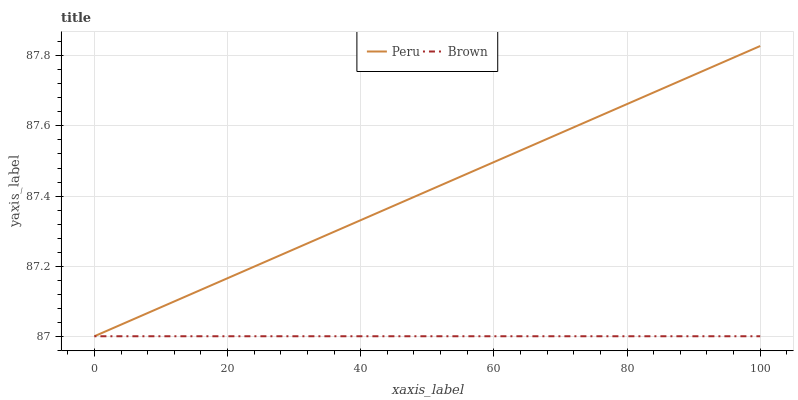Does Brown have the minimum area under the curve?
Answer yes or no. Yes. Does Peru have the maximum area under the curve?
Answer yes or no. Yes. Does Peru have the minimum area under the curve?
Answer yes or no. No. Is Brown the smoothest?
Answer yes or no. Yes. Is Peru the roughest?
Answer yes or no. Yes. Is Peru the smoothest?
Answer yes or no. No. Does Brown have the lowest value?
Answer yes or no. Yes. Does Peru have the highest value?
Answer yes or no. Yes. Does Peru intersect Brown?
Answer yes or no. Yes. Is Peru less than Brown?
Answer yes or no. No. Is Peru greater than Brown?
Answer yes or no. No. 